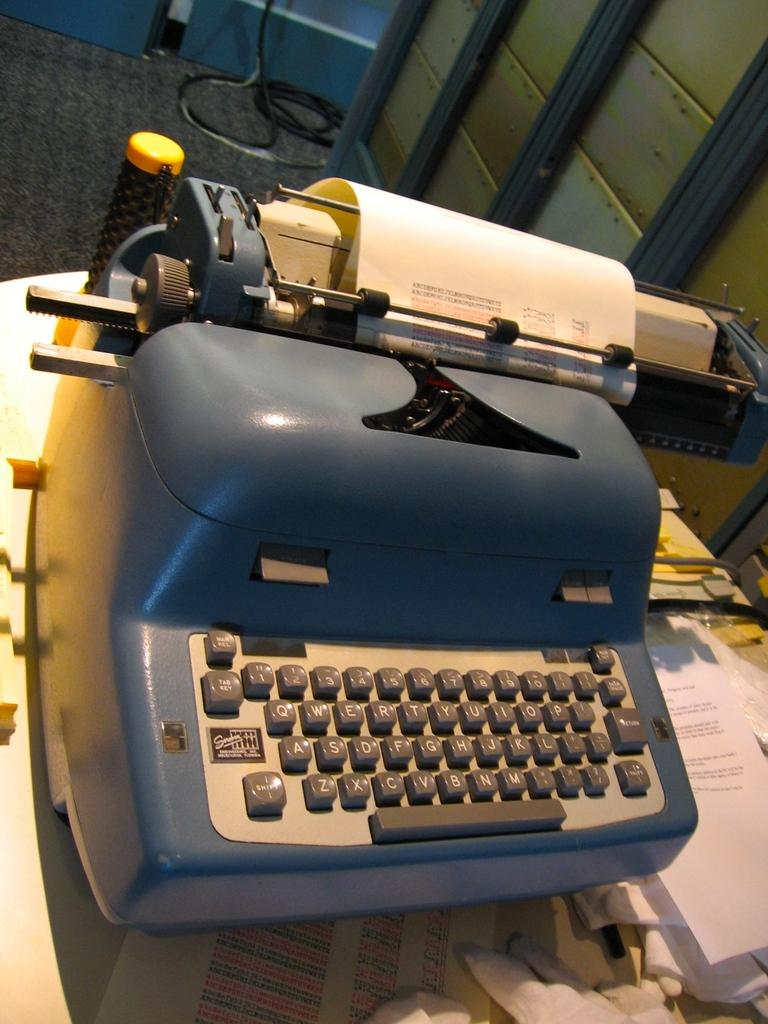<image>
Describe the image concisely. An antique typewriter has the shift key in the lower-left corner of the keyboard. 